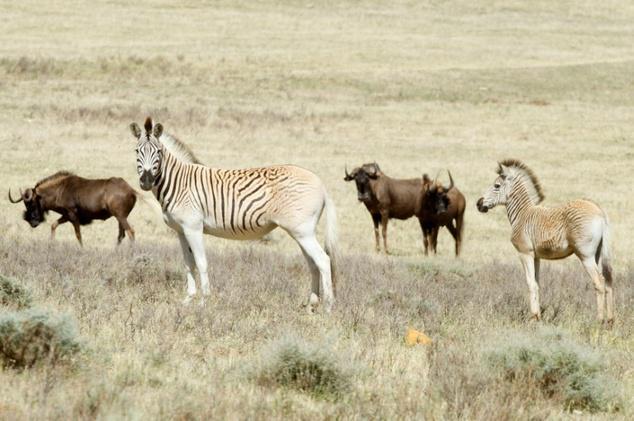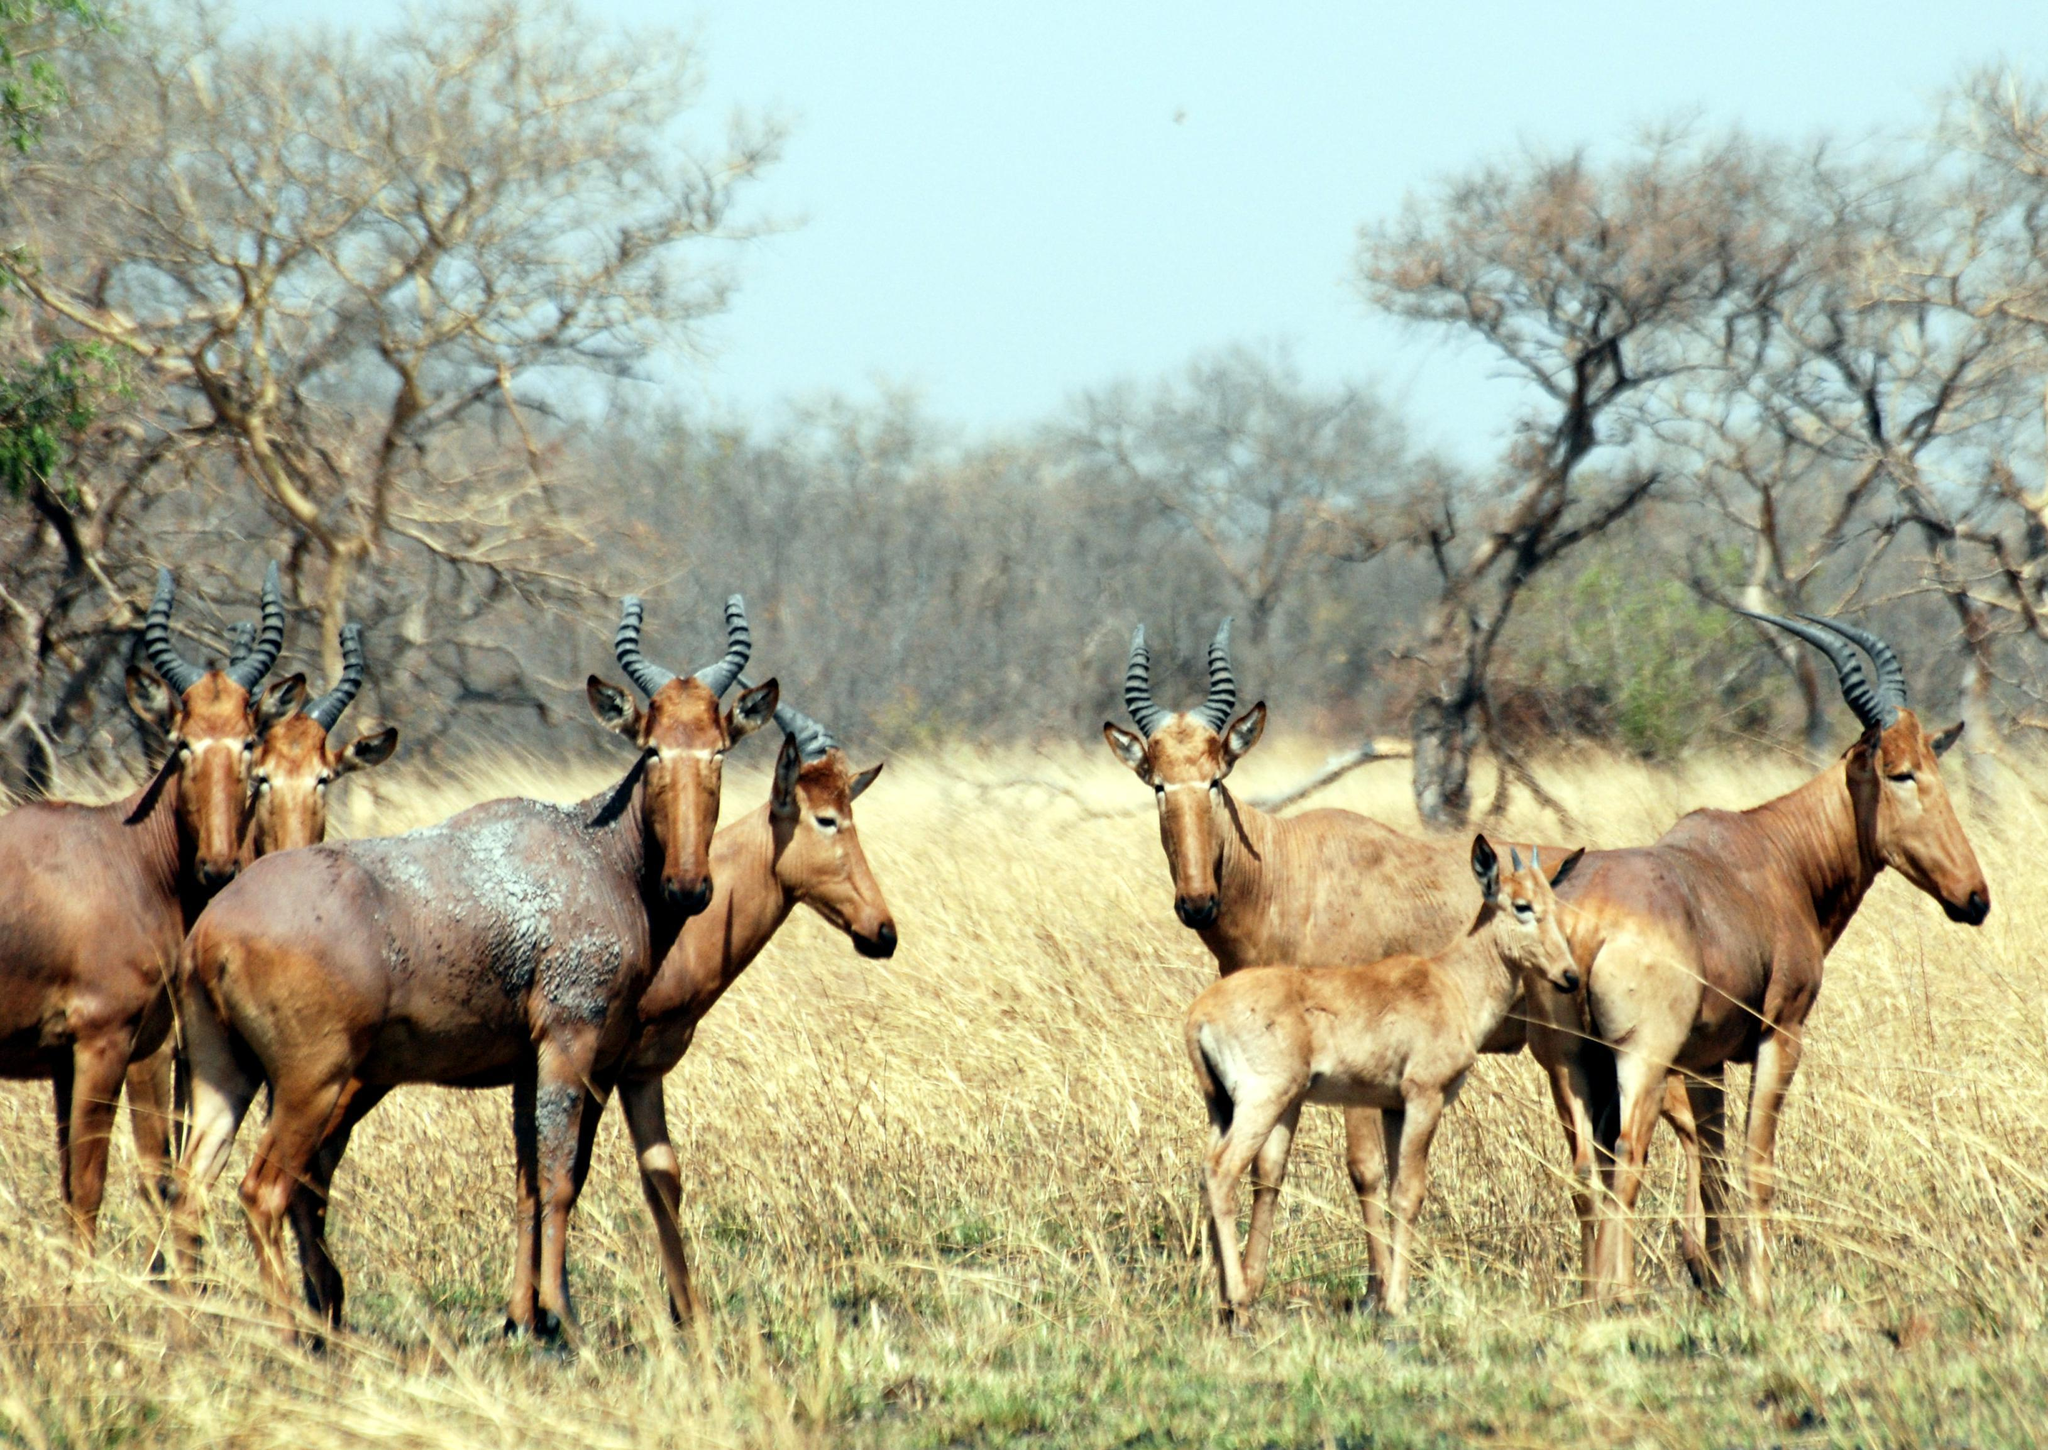The first image is the image on the left, the second image is the image on the right. Examine the images to the left and right. Is the description "there are two zebras in one of the images" accurate? Answer yes or no. Yes. The first image is the image on the left, the second image is the image on the right. Given the left and right images, does the statement "One image contains a zebra." hold true? Answer yes or no. Yes. 